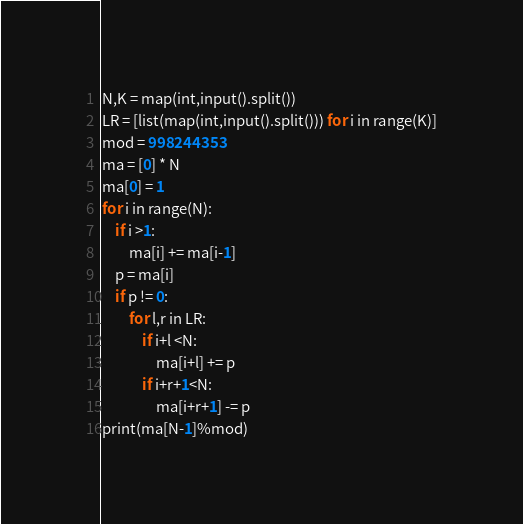Convert code to text. <code><loc_0><loc_0><loc_500><loc_500><_Python_>N,K = map(int,input().split())
LR = [list(map(int,input().split())) for i in range(K)]
mod = 998244353
ma = [0] * N
ma[0] = 1
for i in range(N):
    if i >1:
        ma[i] += ma[i-1]
    p = ma[i]
    if p != 0:
        for l,r in LR:
            if i+l <N:
                ma[i+l] += p
            if i+r+1<N:
                ma[i+r+1] -= p
print(ma[N-1]%mod)</code> 